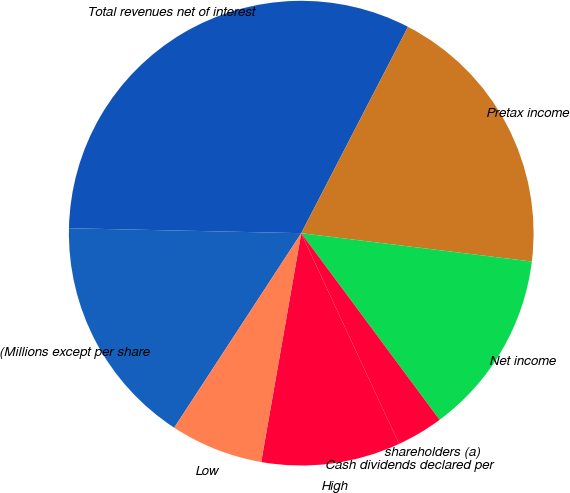Convert chart. <chart><loc_0><loc_0><loc_500><loc_500><pie_chart><fcel>(Millions except per share<fcel>Total revenues net of interest<fcel>Pretax income<fcel>Net income<fcel>shareholders (a)<fcel>Cash dividends declared per<fcel>High<fcel>Low<nl><fcel>16.13%<fcel>32.26%<fcel>19.35%<fcel>12.9%<fcel>3.23%<fcel>0.0%<fcel>9.68%<fcel>6.45%<nl></chart> 